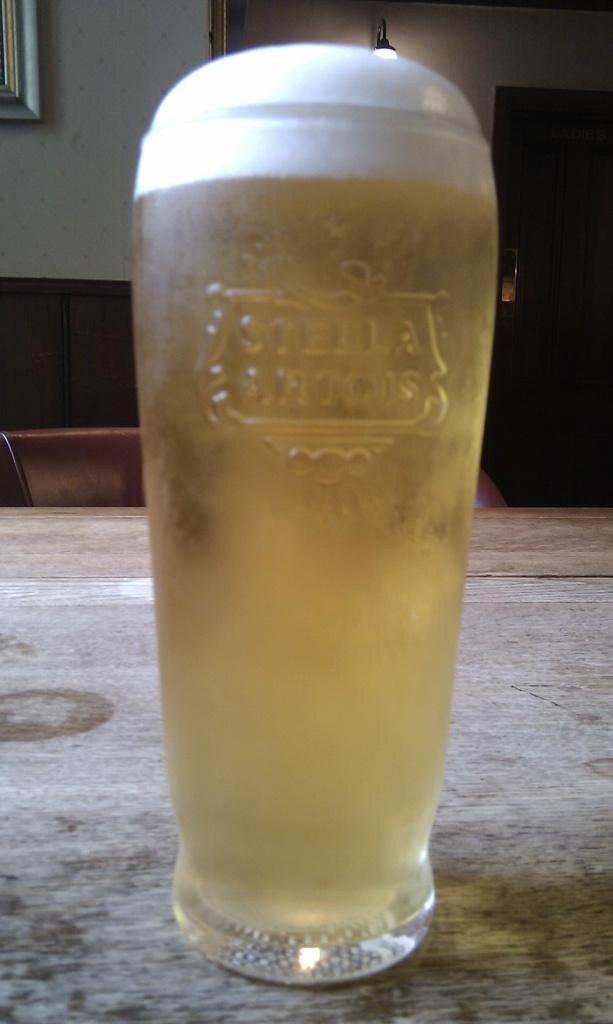Provide a one-sentence caption for the provided image. Stella branded glass is filled to the brim with beer. 